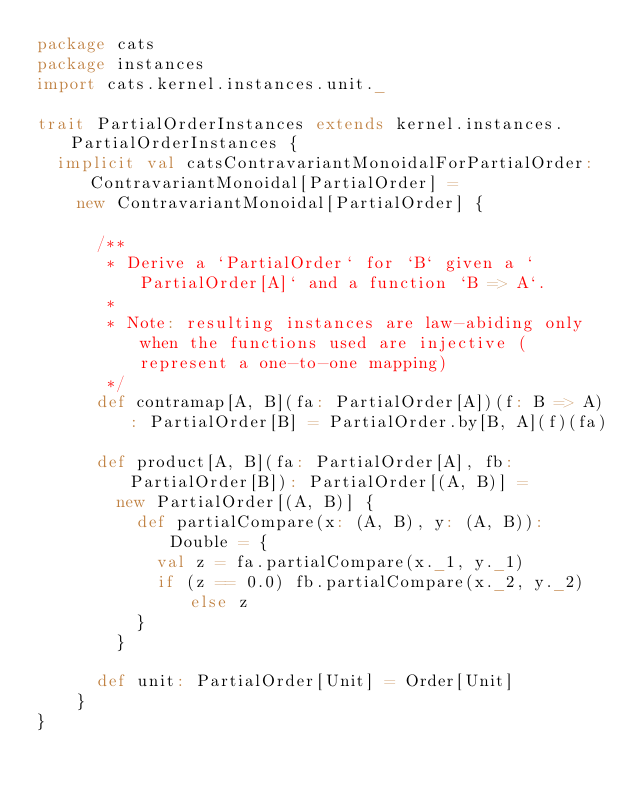Convert code to text. <code><loc_0><loc_0><loc_500><loc_500><_Scala_>package cats
package instances
import cats.kernel.instances.unit._

trait PartialOrderInstances extends kernel.instances.PartialOrderInstances {
  implicit val catsContravariantMonoidalForPartialOrder: ContravariantMonoidal[PartialOrder] =
    new ContravariantMonoidal[PartialOrder] {

      /**
       * Derive a `PartialOrder` for `B` given a `PartialOrder[A]` and a function `B => A`.
       *
       * Note: resulting instances are law-abiding only when the functions used are injective (represent a one-to-one mapping)
       */
      def contramap[A, B](fa: PartialOrder[A])(f: B => A): PartialOrder[B] = PartialOrder.by[B, A](f)(fa)

      def product[A, B](fa: PartialOrder[A], fb: PartialOrder[B]): PartialOrder[(A, B)] =
        new PartialOrder[(A, B)] {
          def partialCompare(x: (A, B), y: (A, B)): Double = {
            val z = fa.partialCompare(x._1, y._1)
            if (z == 0.0) fb.partialCompare(x._2, y._2) else z
          }
        }

      def unit: PartialOrder[Unit] = Order[Unit]
    }
}
</code> 